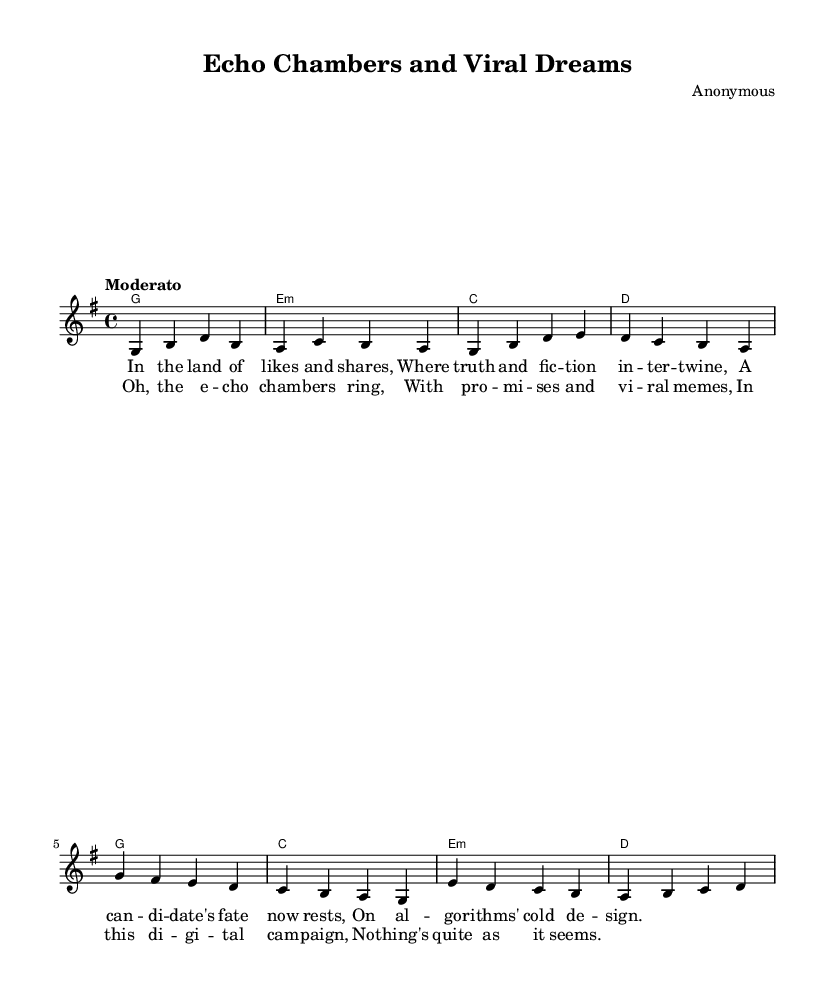What is the key signature of this music? The key signature is G major, which has one sharp (F#). This can be identified in the global section where \key g \major is implemented.
Answer: G major What is the time signature of this music? The time signature is 4/4, which indicates that there are four beats per measure and a quarter note gets one beat. This can be seen in the global section where \time 4/4 is specified.
Answer: 4/4 What is the tempo marking of this music? The tempo marking is "Moderato," which suggests a moderate speed of performance. This is indicated in the global section of the code where \tempo "Moderato" is specified.
Answer: Moderato How many measures are in the verse section? The verse section contains four measures. This can be counted by looking at the melody lines and the corresponding harmonies where the verse notes are organized into four distinct bars.
Answer: 4 Which chord follows the first melody note in the verse? The chord that follows the first melody note (G) is G major. This is identified by the chord mode on the first measure of the verse, where it shows a G major chord aligned with the first melody note.
Answer: G What is the primary theme of the lyrics in this song? The primary theme of the lyrics revolves around the influence of social media on political campaigns and the blend of truth and fiction in this digital age. This can be discerned from key phrases like "echo chambers" and "algorithms' cold design."
Answer: Influence of social media What is the chord structure used in the chorus? The chord structure in the chorus follows a specific pattern: G major, C major, E minor, and D major in sequence. This can be deduced from the chords presented under the chorus melody notes in the harmonies section.
Answer: G, C, E minor, D 